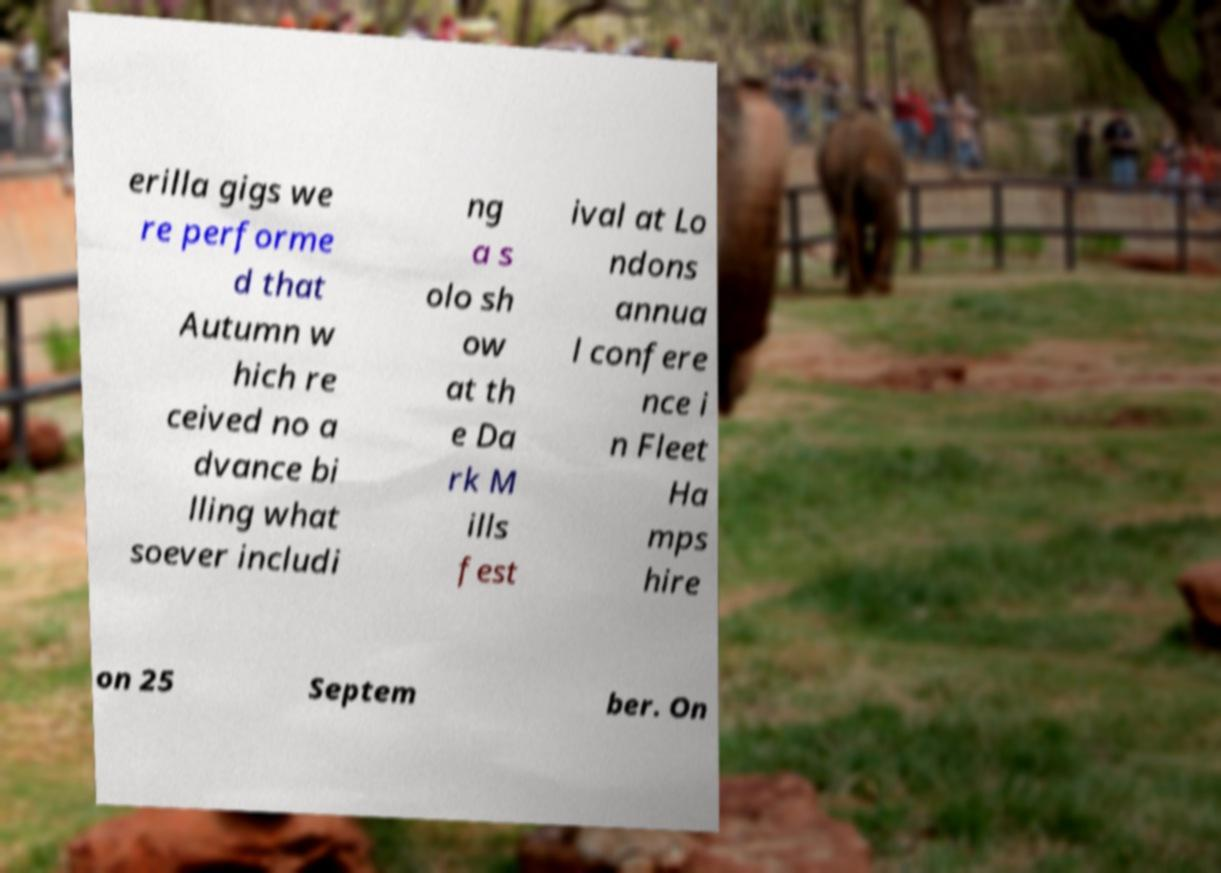Could you extract and type out the text from this image? erilla gigs we re performe d that Autumn w hich re ceived no a dvance bi lling what soever includi ng a s olo sh ow at th e Da rk M ills fest ival at Lo ndons annua l confere nce i n Fleet Ha mps hire on 25 Septem ber. On 